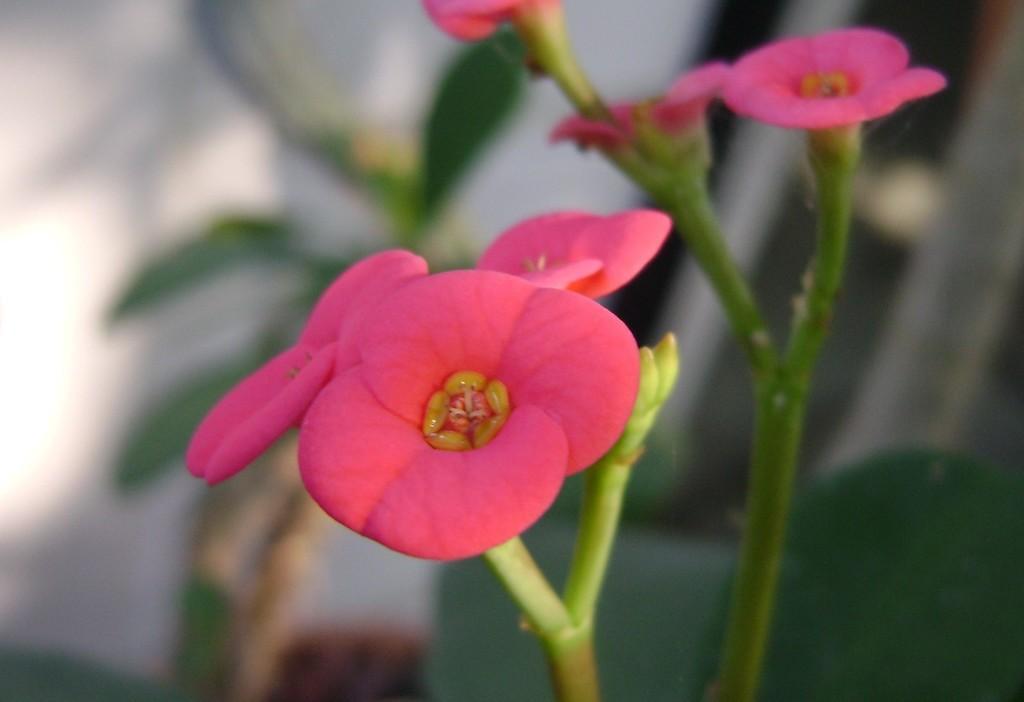In one or two sentences, can you explain what this image depicts? In this picture I can see flowers with stems, and there is blur background. 